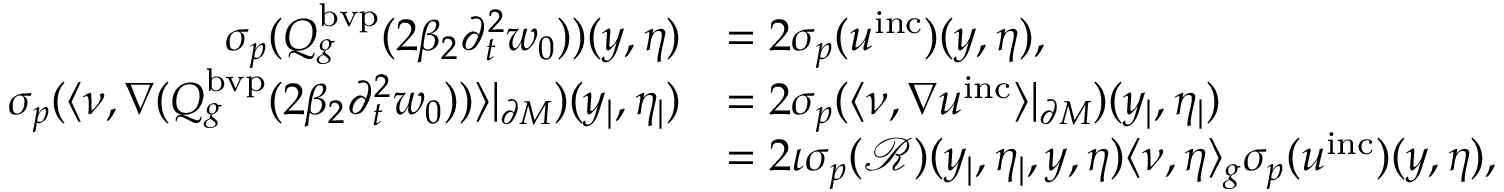<formula> <loc_0><loc_0><loc_500><loc_500>\begin{array} { r l } { { \sigma _ { p } } ( Q _ { g } ^ { b v p } ( 2 \beta _ { 2 } \partial _ { t } ^ { 2 } w _ { 0 } ) ) ( y , \eta ) } & { = 2 { \sigma _ { p } } ( u ^ { i n c } ) ( y , \eta ) , } \\ { { \sigma _ { p } } ( \langle \nu , \nabla ( Q _ { g } ^ { b v p } ( 2 \beta _ { 2 } \partial _ { t } ^ { 2 } w _ { 0 } ) ) \rangle | _ { \partial M } ) ( y _ { | } , \eta _ { | } ) } & { = 2 { \sigma _ { p } } ( \langle \nu , \nabla u ^ { i n c } \rangle | _ { \partial M } ) ( y _ { | } , \eta _ { | } ) } \\ & { = 2 \iota { \sigma _ { p } } ( \mathcal { R } ) ( y _ { | } , \eta _ { | } , y , \eta ) \langle \nu , \eta \rangle _ { g } { \sigma _ { p } } ( u ^ { i n c } ) ( y , \eta ) , } \end{array}</formula> 